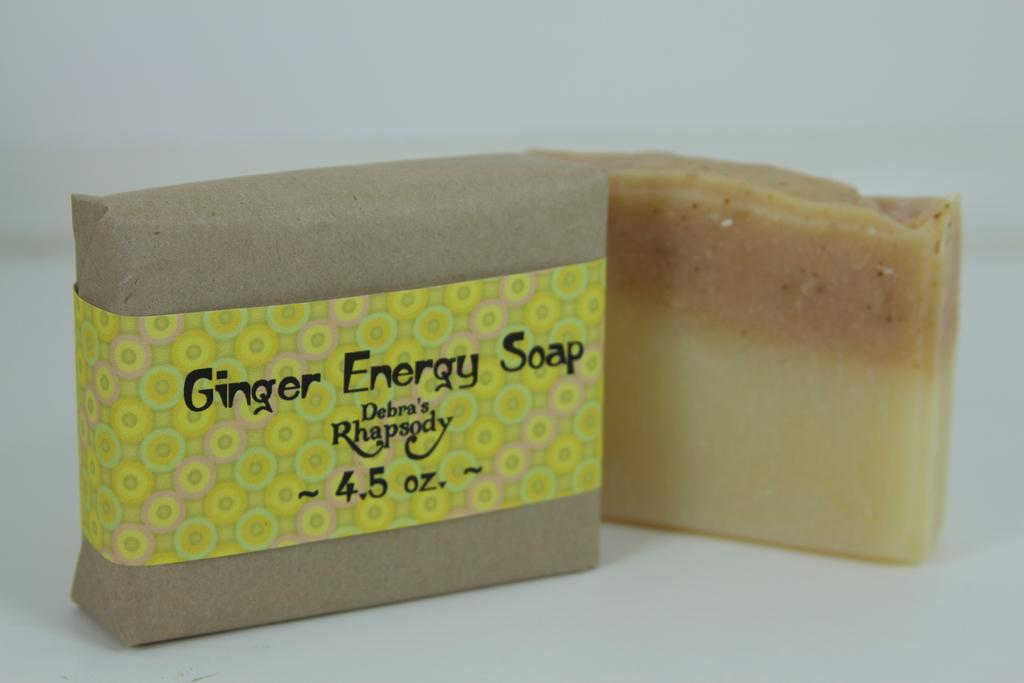What is the main object in the image? There is a soap in the image. How is the soap in the image being presented? The soap is covered with a brown-colored cover. Are there any other soaps visible in the image? Yes, there is another soap beside the covered soap. What type of hammer is being used to fly the airplane in the image? There is no hammer or airplane present in the image; it only features soaps. 